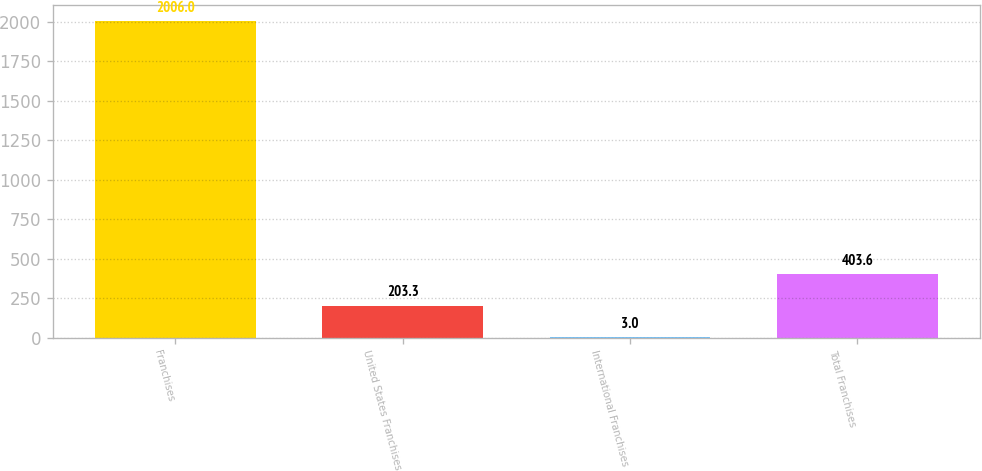Convert chart. <chart><loc_0><loc_0><loc_500><loc_500><bar_chart><fcel>Franchises<fcel>United States Franchises<fcel>International Franchises<fcel>Total Franchises<nl><fcel>2006<fcel>203.3<fcel>3<fcel>403.6<nl></chart> 